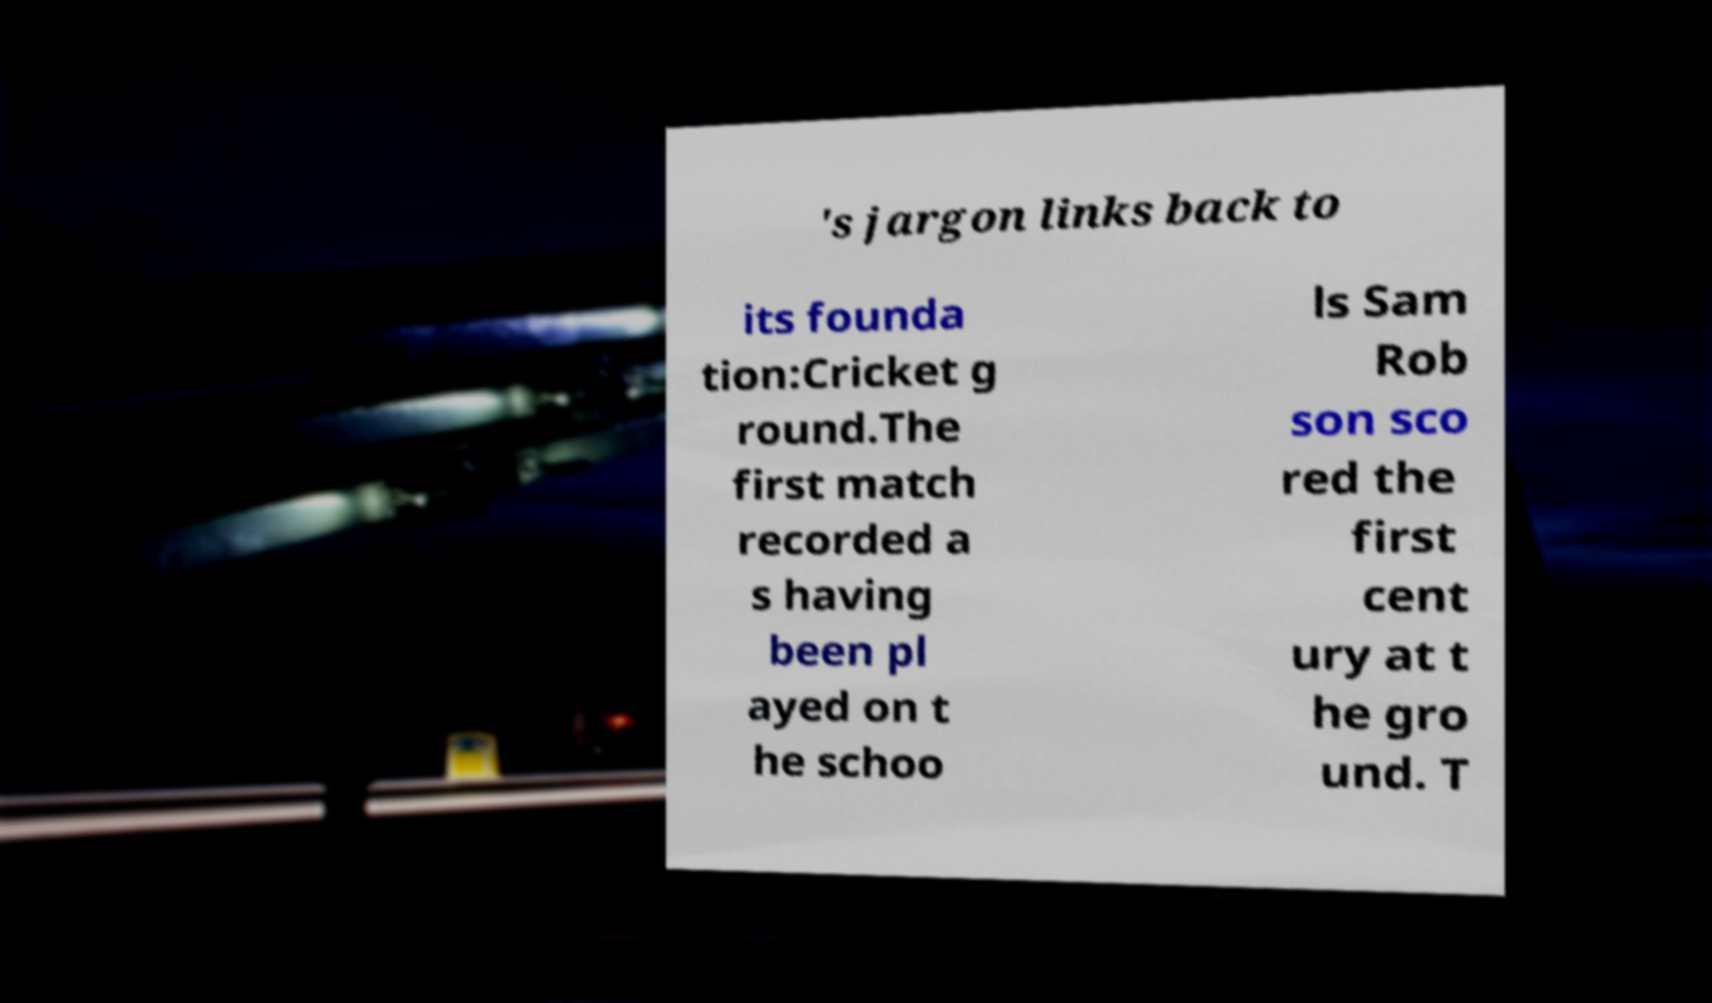Can you accurately transcribe the text from the provided image for me? 's jargon links back to its founda tion:Cricket g round.The first match recorded a s having been pl ayed on t he schoo ls Sam Rob son sco red the first cent ury at t he gro und. T 